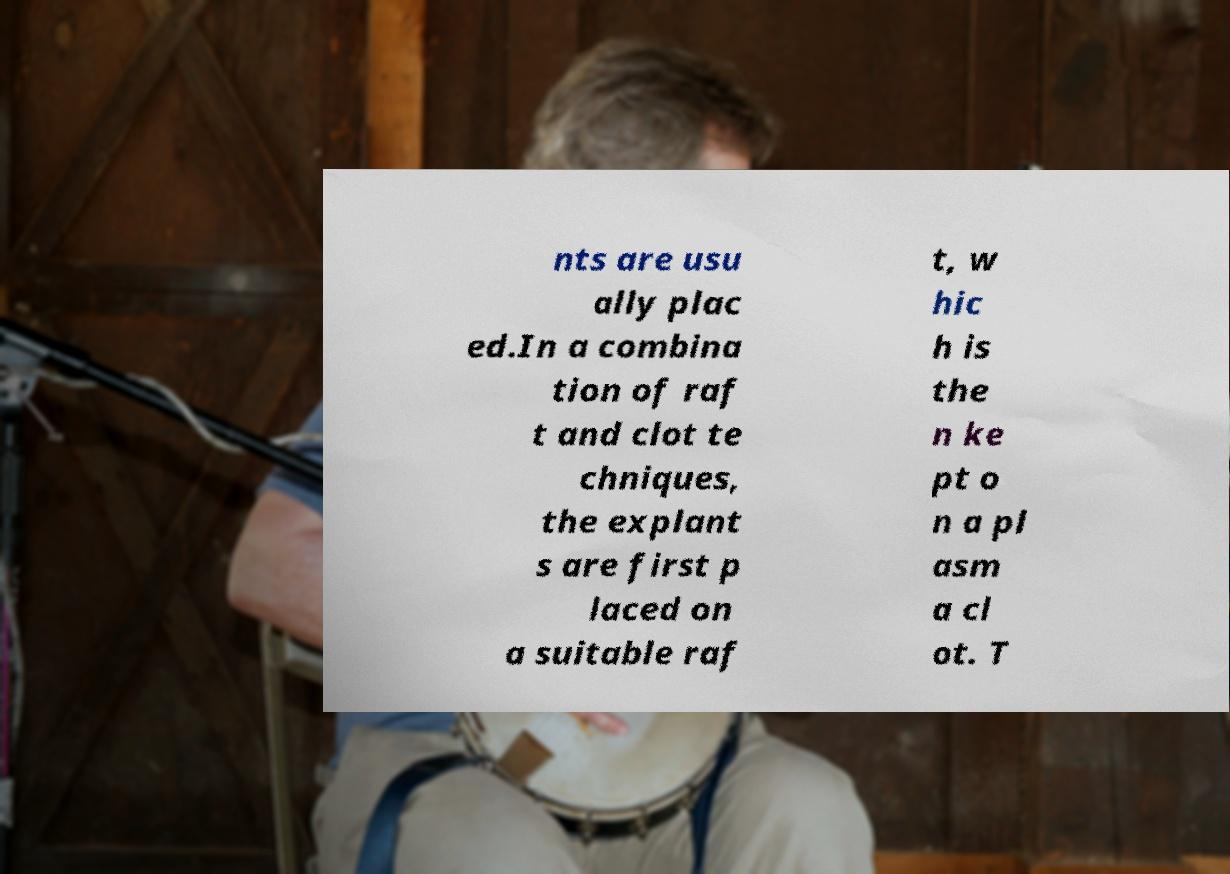Can you accurately transcribe the text from the provided image for me? nts are usu ally plac ed.In a combina tion of raf t and clot te chniques, the explant s are first p laced on a suitable raf t, w hic h is the n ke pt o n a pl asm a cl ot. T 